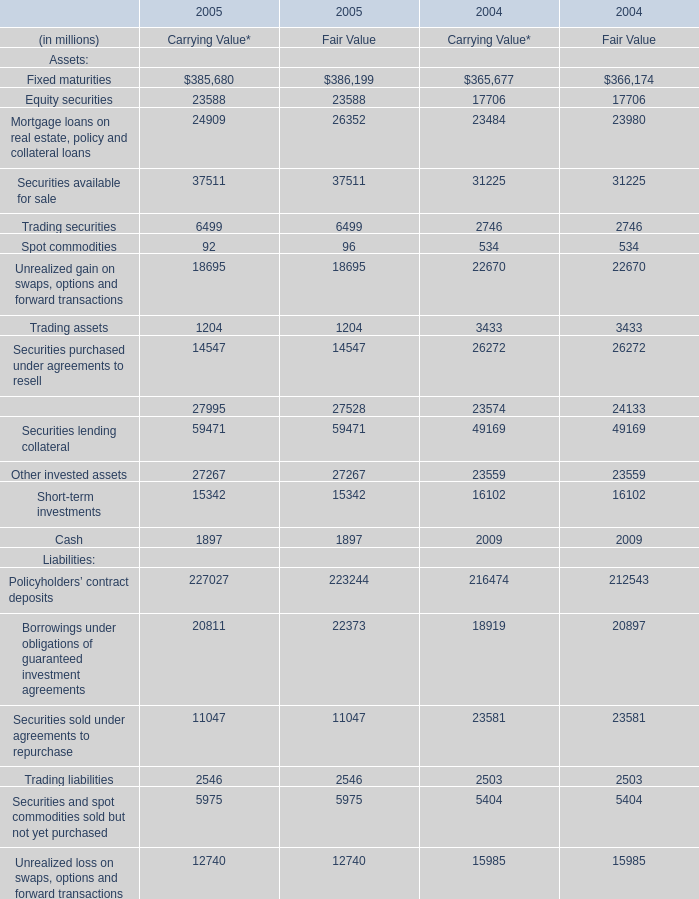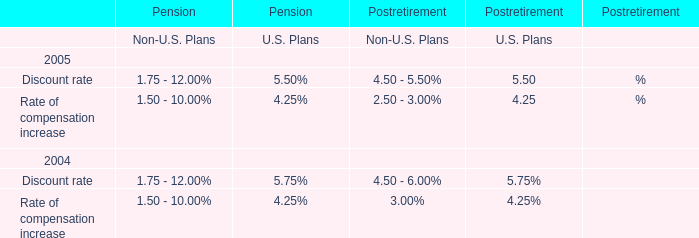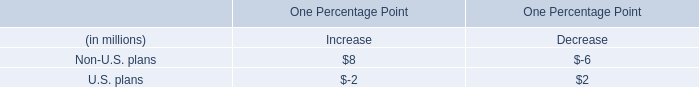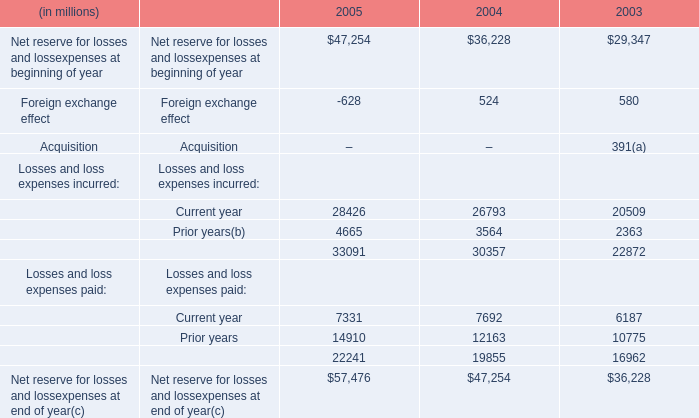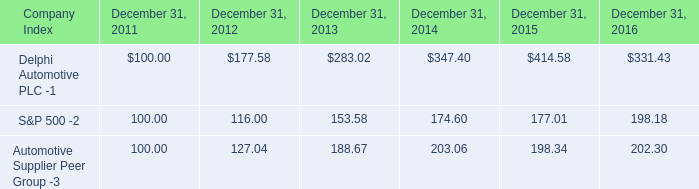what was the percentage return for the 5 year period ending december 31 2016 of delphi automotive plc? 
Computations: ((331.43 - 100) / 100)
Answer: 2.3143. 